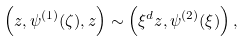Convert formula to latex. <formula><loc_0><loc_0><loc_500><loc_500>\left ( z , \psi ^ { ( 1 ) } ( \zeta ) , z \right ) \sim \left ( \xi ^ { d } z , \psi ^ { ( 2 ) } ( \xi ) \right ) ,</formula> 